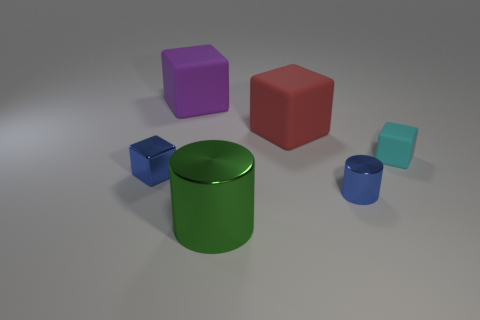Add 3 large red objects. How many objects exist? 9 Subtract all red cubes. How many cubes are left? 3 Subtract all cylinders. How many objects are left? 4 Subtract all gray blocks. Subtract all green balls. How many blocks are left? 4 Subtract all purple cylinders. How many blue cubes are left? 1 Subtract all brown things. Subtract all metallic cylinders. How many objects are left? 4 Add 6 cyan cubes. How many cyan cubes are left? 7 Add 3 cyan rubber things. How many cyan rubber things exist? 4 Subtract all blue cylinders. How many cylinders are left? 1 Subtract 0 gray spheres. How many objects are left? 6 